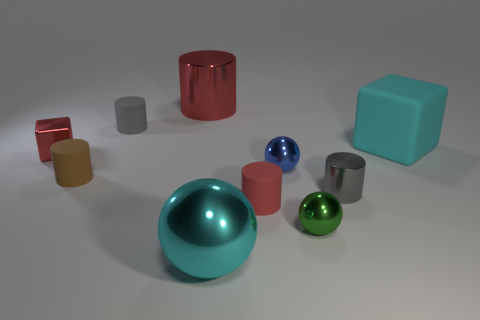Subtract 2 cylinders. How many cylinders are left? 3 Subtract all brown cylinders. How many cylinders are left? 4 Subtract all brown matte cylinders. How many cylinders are left? 4 Subtract all cyan cylinders. Subtract all yellow blocks. How many cylinders are left? 5 Subtract all spheres. How many objects are left? 7 Subtract all small green rubber cubes. Subtract all big cylinders. How many objects are left? 9 Add 7 large cyan cubes. How many large cyan cubes are left? 8 Add 7 large cubes. How many large cubes exist? 8 Subtract 0 brown balls. How many objects are left? 10 